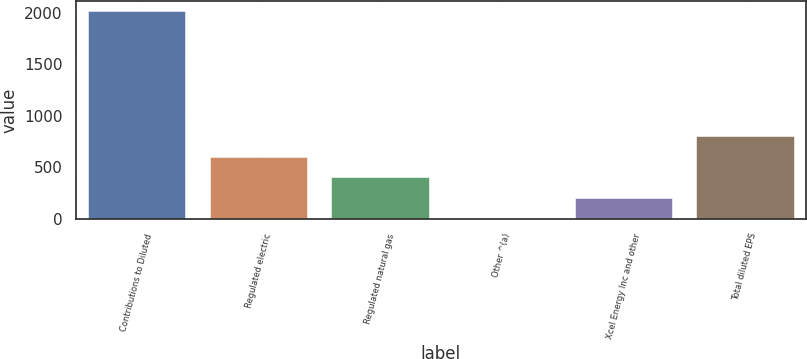Convert chart to OTSL. <chart><loc_0><loc_0><loc_500><loc_500><bar_chart><fcel>Contributions to Diluted<fcel>Regulated electric<fcel>Regulated natural gas<fcel>Other ^(a)<fcel>Xcel Energy Inc and other<fcel>Total diluted EPS<nl><fcel>2015<fcel>604.53<fcel>403.03<fcel>0.03<fcel>201.53<fcel>806.03<nl></chart> 